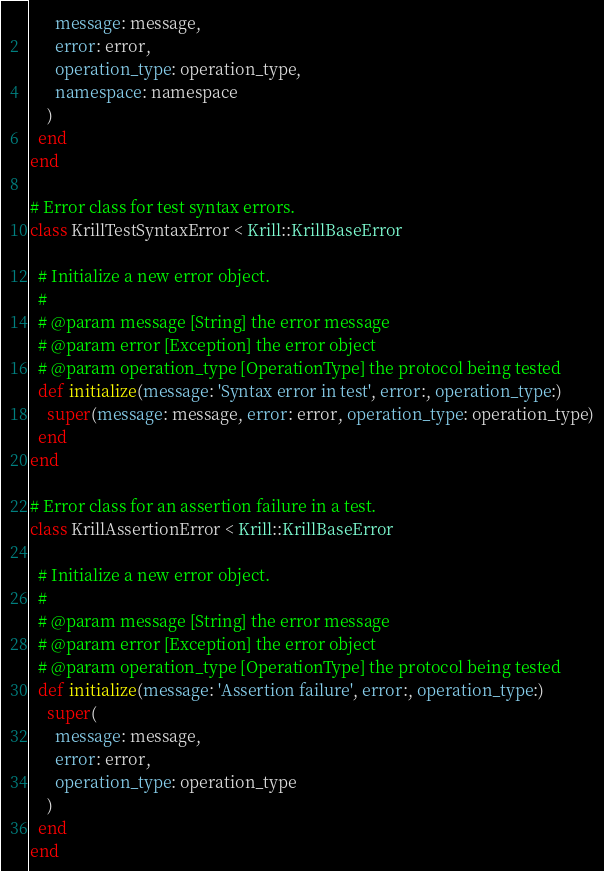Convert code to text. <code><loc_0><loc_0><loc_500><loc_500><_Ruby_>      message: message,
      error: error,
      operation_type: operation_type,
      namespace: namespace
    )
  end
end

# Error class for test syntax errors.
class KrillTestSyntaxError < Krill::KrillBaseError

  # Initialize a new error object.
  #
  # @param message [String] the error message
  # @param error [Exception] the error object
  # @param operation_type [OperationType] the protocol being tested
  def initialize(message: 'Syntax error in test', error:, operation_type:)
    super(message: message, error: error, operation_type: operation_type)
  end
end

# Error class for an assertion failure in a test.
class KrillAssertionError < Krill::KrillBaseError

  # Initialize a new error object.
  #
  # @param message [String] the error message
  # @param error [Exception] the error object
  # @param operation_type [OperationType] the protocol being tested
  def initialize(message: 'Assertion failure', error:, operation_type:)
    super(
      message: message,
      error: error,
      operation_type: operation_type
    )
  end
end
</code> 